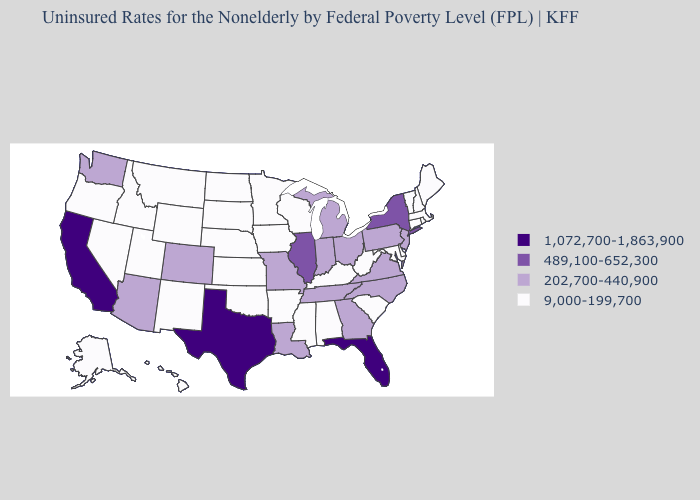Name the states that have a value in the range 1,072,700-1,863,900?
Be succinct. California, Florida, Texas. Which states hav the highest value in the Northeast?
Give a very brief answer. New York. Does the first symbol in the legend represent the smallest category?
Quick response, please. No. Does Georgia have the lowest value in the USA?
Short answer required. No. What is the highest value in states that border New York?
Give a very brief answer. 202,700-440,900. Does Arizona have a lower value than Colorado?
Keep it brief. No. Does Kentucky have the same value as Maryland?
Write a very short answer. Yes. Does the map have missing data?
Answer briefly. No. Does Rhode Island have the highest value in the USA?
Be succinct. No. Which states have the highest value in the USA?
Answer briefly. California, Florida, Texas. Among the states that border Tennessee , does Missouri have the highest value?
Answer briefly. Yes. Name the states that have a value in the range 9,000-199,700?
Answer briefly. Alabama, Alaska, Arkansas, Connecticut, Delaware, Hawaii, Idaho, Iowa, Kansas, Kentucky, Maine, Maryland, Massachusetts, Minnesota, Mississippi, Montana, Nebraska, Nevada, New Hampshire, New Mexico, North Dakota, Oklahoma, Oregon, Rhode Island, South Carolina, South Dakota, Utah, Vermont, West Virginia, Wisconsin, Wyoming. Name the states that have a value in the range 9,000-199,700?
Write a very short answer. Alabama, Alaska, Arkansas, Connecticut, Delaware, Hawaii, Idaho, Iowa, Kansas, Kentucky, Maine, Maryland, Massachusetts, Minnesota, Mississippi, Montana, Nebraska, Nevada, New Hampshire, New Mexico, North Dakota, Oklahoma, Oregon, Rhode Island, South Carolina, South Dakota, Utah, Vermont, West Virginia, Wisconsin, Wyoming. Among the states that border Delaware , which have the highest value?
Answer briefly. New Jersey, Pennsylvania. Is the legend a continuous bar?
Keep it brief. No. 